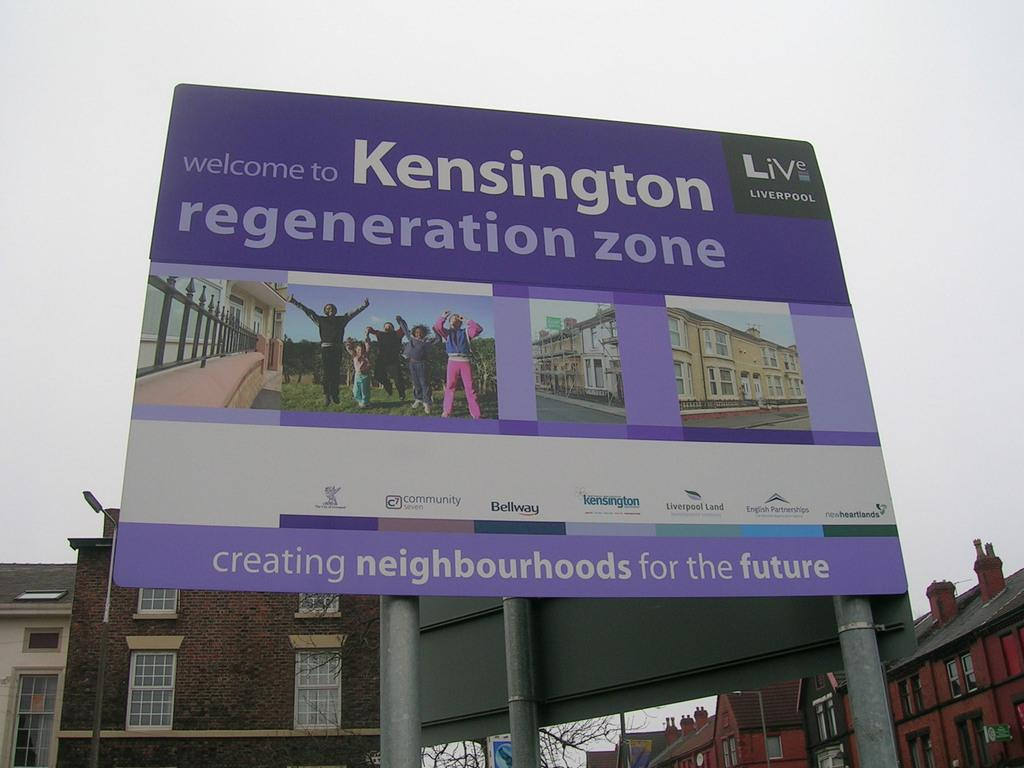<image>
Share a concise interpretation of the image provided. the word Kensington is on the purple sign 